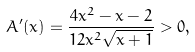Convert formula to latex. <formula><loc_0><loc_0><loc_500><loc_500>A ^ { \prime } ( x ) = \frac { 4 x ^ { 2 } - x - 2 } { 1 2 x ^ { 2 } \sqrt { x + 1 } } > 0 ,</formula> 